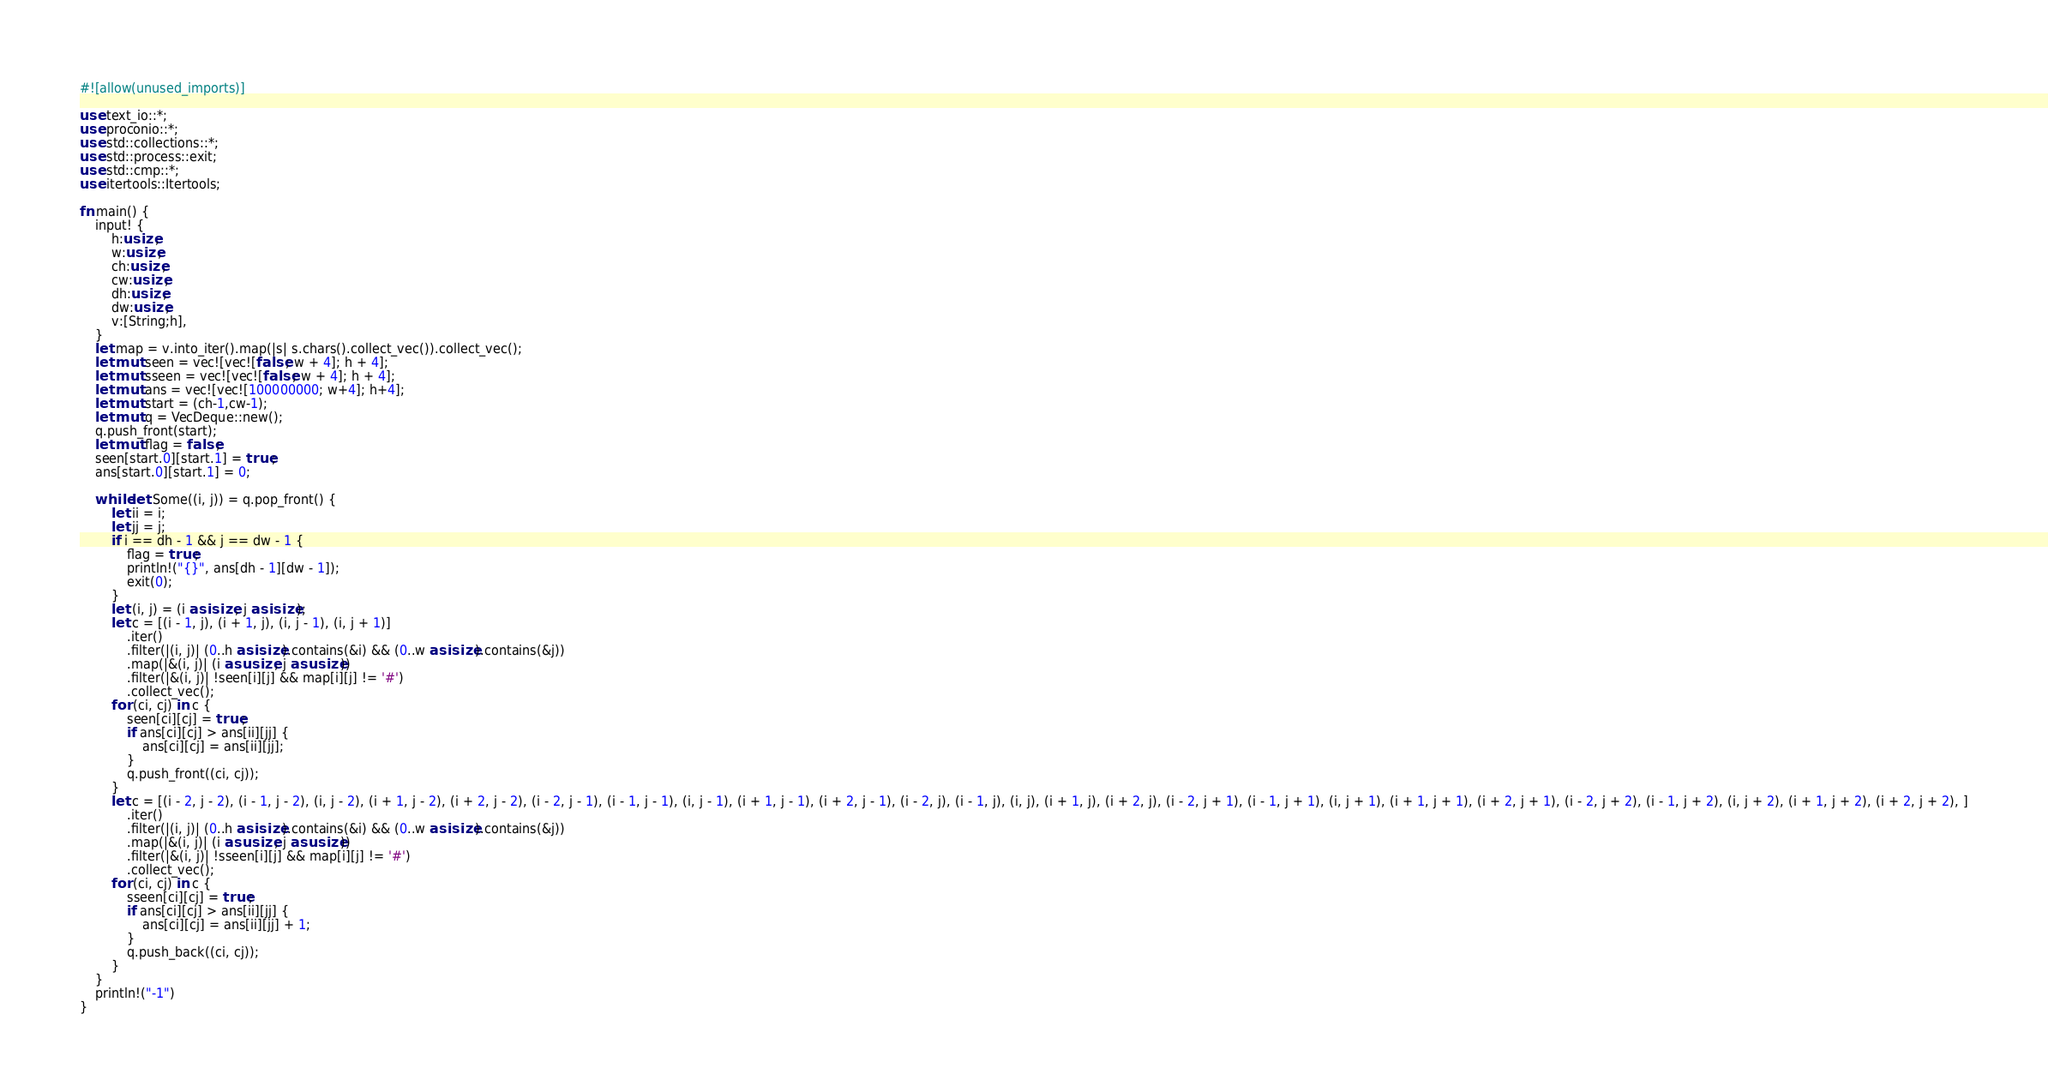Convert code to text. <code><loc_0><loc_0><loc_500><loc_500><_Rust_>#![allow(unused_imports)]

use text_io::*;
use proconio::*;
use std::collections::*;
use std::process::exit;
use std::cmp::*;
use itertools::Itertools;

fn main() {
    input! {
        h:usize,
        w:usize,
        ch:usize,
        cw:usize,
        dh:usize,
        dw:usize,
        v:[String;h],
    }
    let map = v.into_iter().map(|s| s.chars().collect_vec()).collect_vec();
    let mut seen = vec![vec![false; w + 4]; h + 4];
    let mut sseen = vec![vec![false; w + 4]; h + 4];
    let mut ans = vec![vec![100000000; w+4]; h+4];
    let mut start = (ch-1,cw-1);
    let mut q = VecDeque::new();
    q.push_front(start);
    let mut flag = false;
    seen[start.0][start.1] = true;
    ans[start.0][start.1] = 0;

    while let Some((i, j)) = q.pop_front() {
        let ii = i;
        let jj = j;
        if i == dh - 1 && j == dw - 1 {
            flag = true;
            println!("{}", ans[dh - 1][dw - 1]);
            exit(0);
        }
        let (i, j) = (i as isize, j as isize);
        let c = [(i - 1, j), (i + 1, j), (i, j - 1), (i, j + 1)]
            .iter()
            .filter(|(i, j)| (0..h as isize).contains(&i) && (0..w as isize).contains(&j))
            .map(|&(i, j)| (i as usize, j as usize))
            .filter(|&(i, j)| !seen[i][j] && map[i][j] != '#')
            .collect_vec();
        for (ci, cj) in c {
            seen[ci][cj] = true;
            if ans[ci][cj] > ans[ii][jj] {
                ans[ci][cj] = ans[ii][jj];
            }
            q.push_front((ci, cj));
        }
        let c = [(i - 2, j - 2), (i - 1, j - 2), (i, j - 2), (i + 1, j - 2), (i + 2, j - 2), (i - 2, j - 1), (i - 1, j - 1), (i, j - 1), (i + 1, j - 1), (i + 2, j - 1), (i - 2, j), (i - 1, j), (i, j), (i + 1, j), (i + 2, j), (i - 2, j + 1), (i - 1, j + 1), (i, j + 1), (i + 1, j + 1), (i + 2, j + 1), (i - 2, j + 2), (i - 1, j + 2), (i, j + 2), (i + 1, j + 2), (i + 2, j + 2), ]
            .iter()
            .filter(|(i, j)| (0..h as isize).contains(&i) && (0..w as isize).contains(&j))
            .map(|&(i, j)| (i as usize, j as usize))
            .filter(|&(i, j)| !sseen[i][j] && map[i][j] != '#')
            .collect_vec();
        for (ci, cj) in c {
            sseen[ci][cj] = true;
            if ans[ci][cj] > ans[ii][jj] {
                ans[ci][cj] = ans[ii][jj] + 1;
            }
            q.push_back((ci, cj));
        }
    }
    println!("-1")
}</code> 